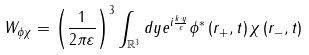Convert formula to latex. <formula><loc_0><loc_0><loc_500><loc_500>W _ { \phi \chi } = \left ( \frac { 1 } { 2 \pi \varepsilon } \right ) ^ { 3 } \int _ { \mathbb { R } ^ { 3 } } d y e ^ { i \frac { k \cdot y } { \varepsilon } } \phi ^ { * } \left ( r _ { + } , t \right ) \chi \left ( r _ { - } , t \right )</formula> 